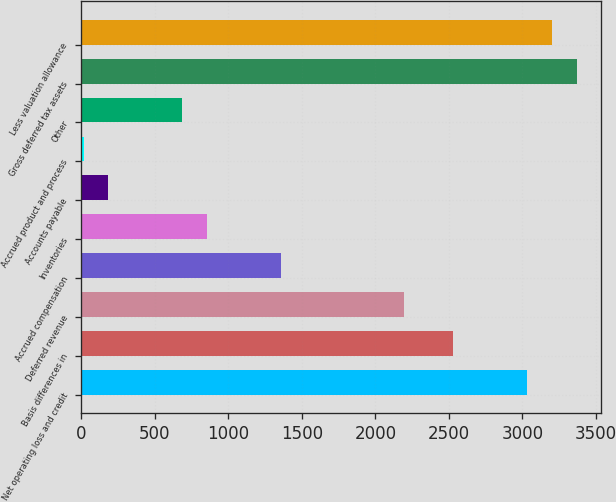<chart> <loc_0><loc_0><loc_500><loc_500><bar_chart><fcel>Net operating loss and credit<fcel>Basis differences in<fcel>Deferred revenue<fcel>Accrued compensation<fcel>Inventories<fcel>Accounts payable<fcel>Accrued product and process<fcel>Other<fcel>Gross deferred tax assets<fcel>Less valuation allowance<nl><fcel>3034.4<fcel>2531<fcel>2195.4<fcel>1356.4<fcel>853<fcel>181.8<fcel>14<fcel>685.2<fcel>3370<fcel>3202.2<nl></chart> 